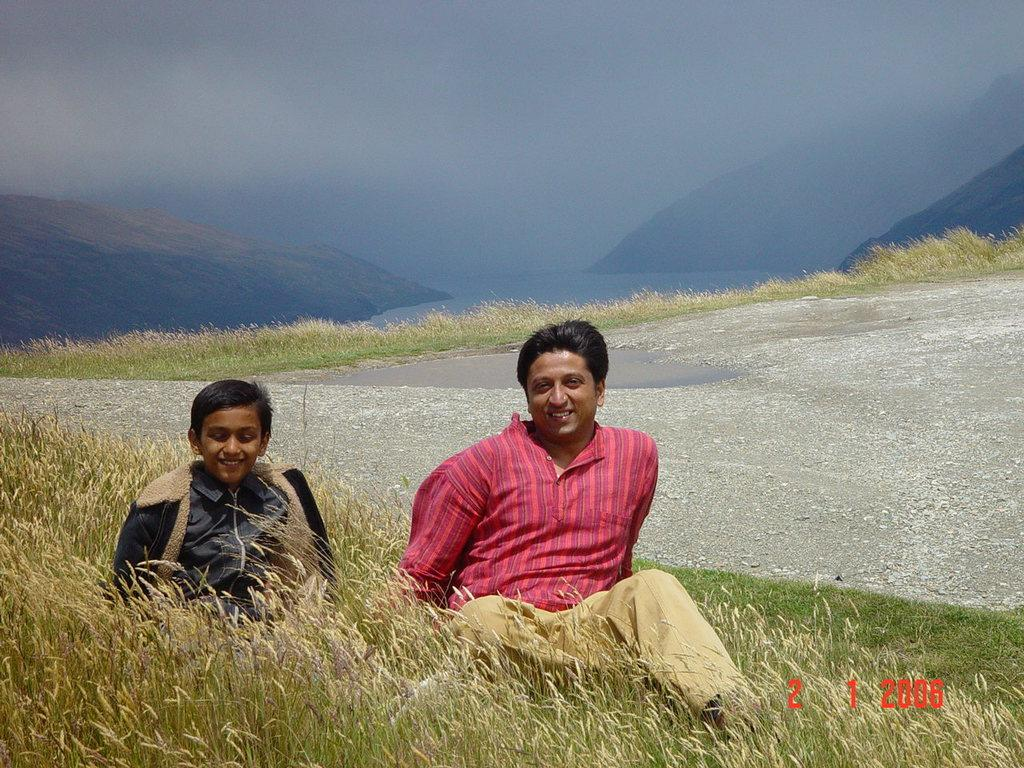Who can be seen in the image? There is a man and a boy in the image. What are they doing in the image? Both the man and the boy are sitting on the grass. What is their facial expression in the image? They are smiling. What type of terrain is visible in the image? There is ground visible in the image. What can be seen in the distance in the image? There are mountains in the background of the image. What else is visible in the background of the image? The sky is visible in the background of the image. What type of boot is the man wearing in the image? There is no boot visible in the image; both the man and the boy are sitting on the grass with their feet exposed. 